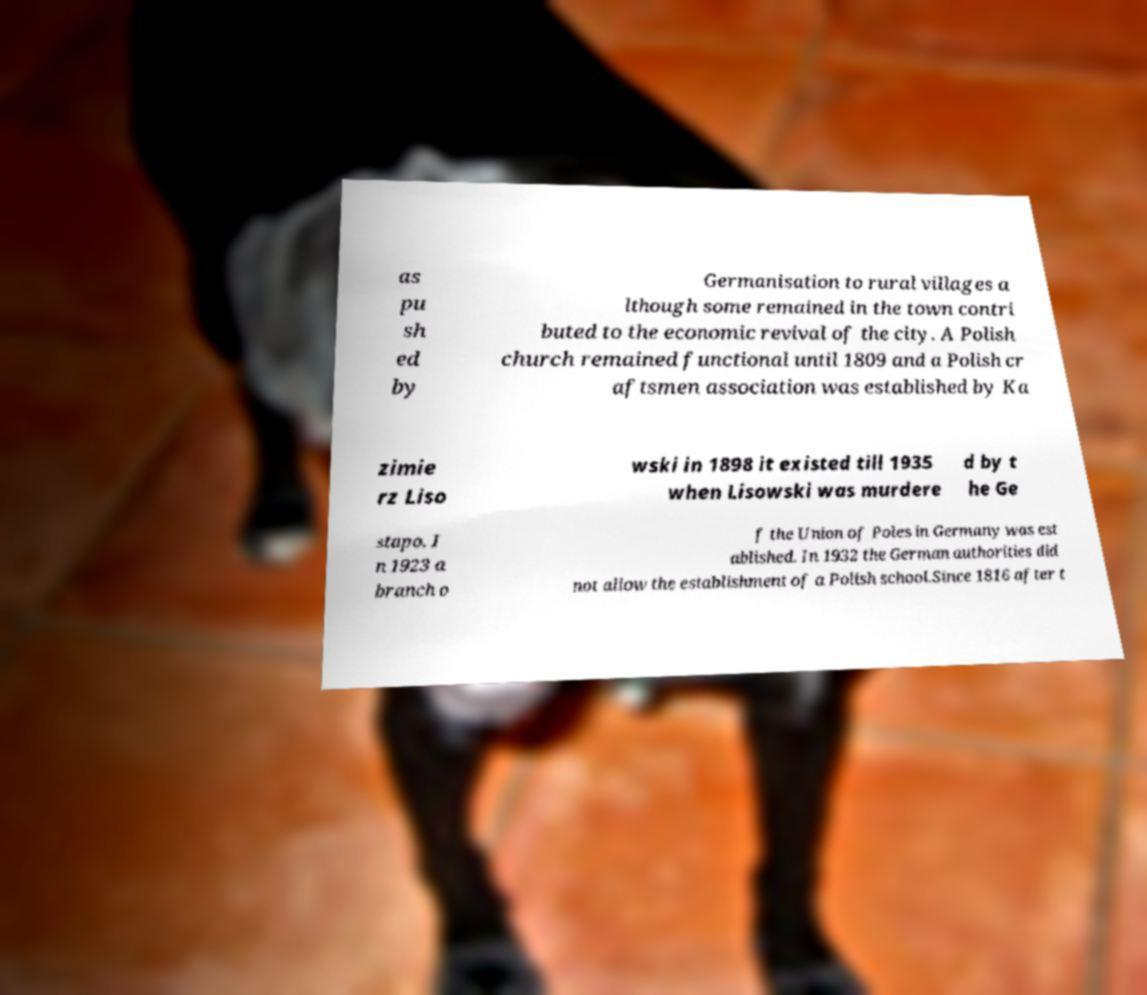I need the written content from this picture converted into text. Can you do that? as pu sh ed by Germanisation to rural villages a lthough some remained in the town contri buted to the economic revival of the city. A Polish church remained functional until 1809 and a Polish cr aftsmen association was established by Ka zimie rz Liso wski in 1898 it existed till 1935 when Lisowski was murdere d by t he Ge stapo. I n 1923 a branch o f the Union of Poles in Germany was est ablished. In 1932 the German authorities did not allow the establishment of a Polish school.Since 1816 after t 